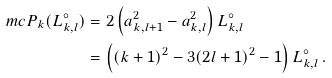<formula> <loc_0><loc_0><loc_500><loc_500>\ m c P _ { k } ( L _ { k , l } ^ { \circ } ) & = 2 \left ( a _ { k , l + 1 } ^ { 2 } - a _ { k , l } ^ { 2 } \right ) L _ { k , l } ^ { \circ } \\ & = \left ( ( k + 1 ) ^ { 2 } - 3 ( 2 l + 1 ) ^ { 2 } - 1 \right ) L _ { k , l } ^ { \circ } \, .</formula> 